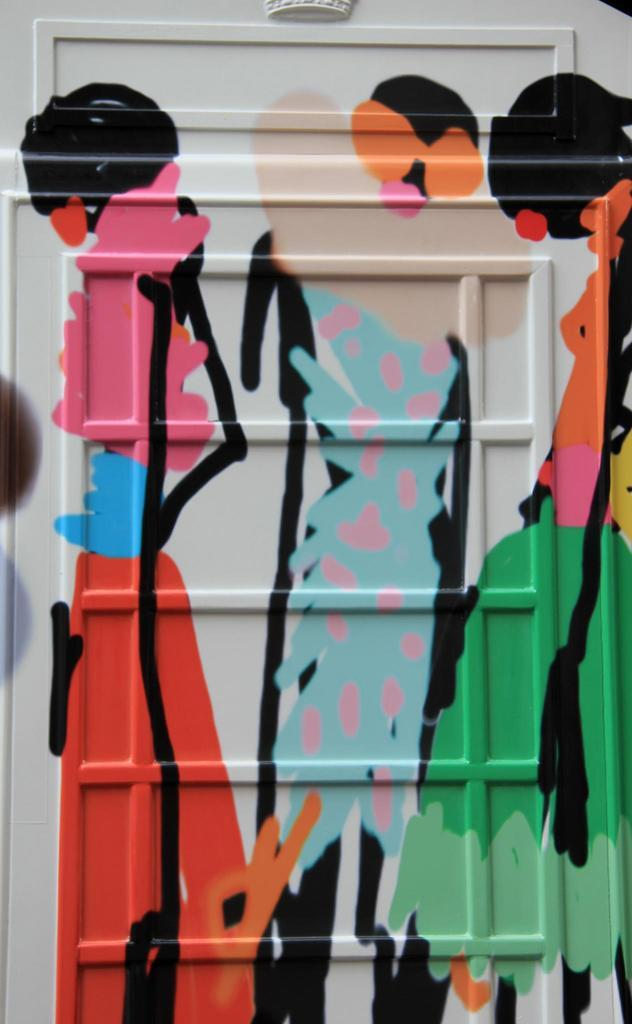What is depicted on the wall in the image? There are paintings on a white wall in the image. What might be the nature of these paintings? The paintings might be a form of graffiti. What colors are used in the paintings? The paintings are in green, blue, and red colors. What is visible in the background of the image? There is a white wall visible in the background of the image. How many centimeters is the year depicted in the image? There is no year depicted in the image, so it cannot be measured in centimeters. 